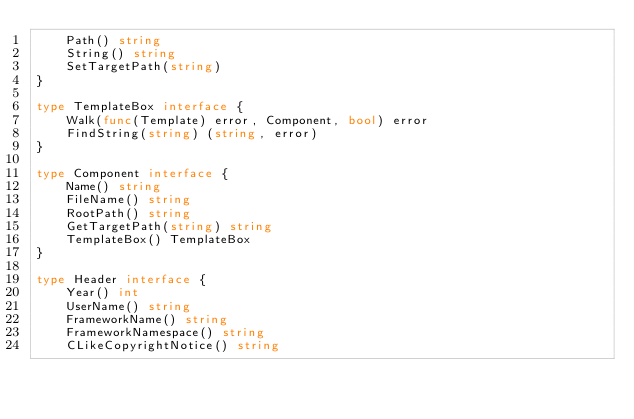Convert code to text. <code><loc_0><loc_0><loc_500><loc_500><_Go_>	Path() string
	String() string
	SetTargetPath(string)
}

type TemplateBox interface {
	Walk(func(Template) error, Component, bool) error
	FindString(string) (string, error)
}

type Component interface {
	Name() string
	FileName() string
	RootPath() string
	GetTargetPath(string) string
	TemplateBox() TemplateBox
}

type Header interface {
	Year() int
	UserName() string
	FrameworkName() string
	FrameworkNamespace() string
	CLikeCopyrightNotice() string</code> 